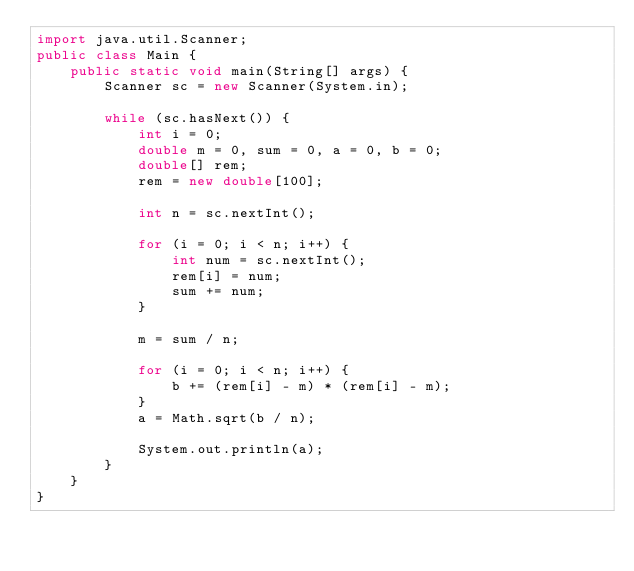Convert code to text. <code><loc_0><loc_0><loc_500><loc_500><_Java_>import java.util.Scanner;
public class Main {
    public static void main(String[] args) {
        Scanner sc = new Scanner(System.in);

        while (sc.hasNext()) {
            int i = 0;
            double m = 0, sum = 0, a = 0, b = 0;
            double[] rem;
            rem = new double[100];

            int n = sc.nextInt();

            for (i = 0; i < n; i++) {
                int num = sc.nextInt();
                rem[i] = num;
                sum += num;
            }

            m = sum / n;

            for (i = 0; i < n; i++) {
                b += (rem[i] - m) * (rem[i] - m);
            }
            a = Math.sqrt(b / n);

            System.out.println(a);
        }
    }
}

</code> 